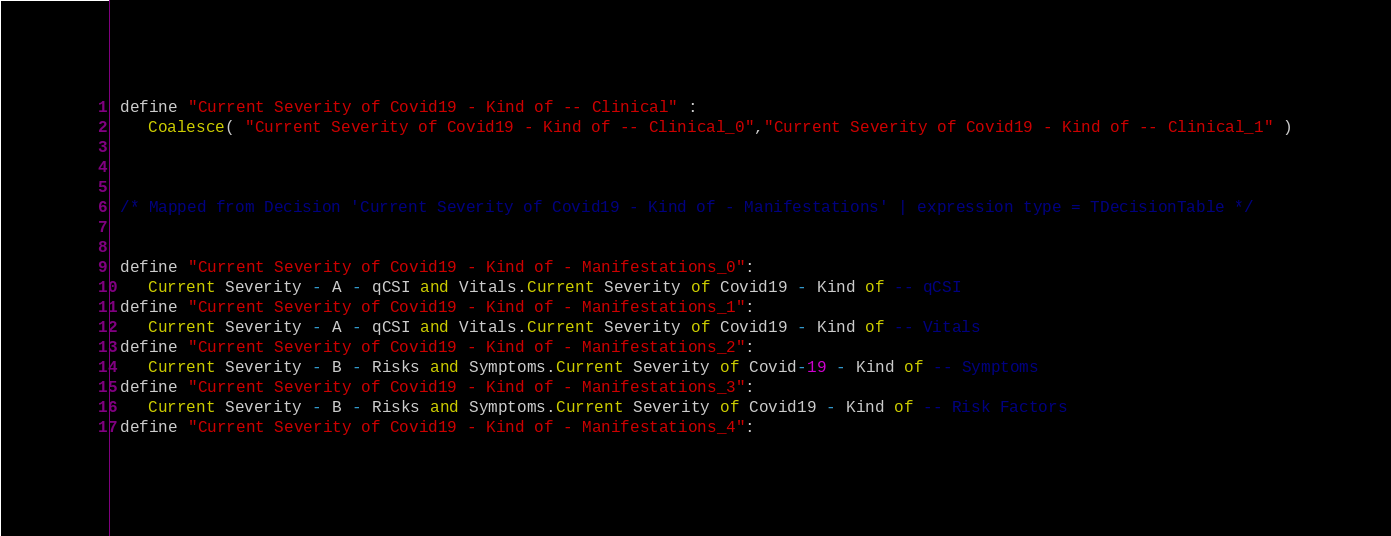<code> <loc_0><loc_0><loc_500><loc_500><_SQL_>
 define "Current Severity of Covid19 - Kind of -- Clinical" :
	Coalesce( "Current Severity of Covid19 - Kind of -- Clinical_0","Current Severity of Covid19 - Kind of -- Clinical_1" )



 /* Mapped from Decision 'Current Severity of Covid19 - Kind of - Manifestations' | expression type = TDecisionTable */ 


 define "Current Severity of Covid19 - Kind of - Manifestations_0": 
	Current Severity - A - qCSI and Vitals.Current Severity of Covid19 - Kind of -- qCSI
 define "Current Severity of Covid19 - Kind of - Manifestations_1": 
	Current Severity - A - qCSI and Vitals.Current Severity of Covid19 - Kind of -- Vitals
 define "Current Severity of Covid19 - Kind of - Manifestations_2": 
	Current Severity - B - Risks and Symptoms.Current Severity of Covid-19 - Kind of -- Symptoms
 define "Current Severity of Covid19 - Kind of - Manifestations_3": 
	Current Severity - B - Risks and Symptoms.Current Severity of Covid19 - Kind of -- Risk Factors
 define "Current Severity of Covid19 - Kind of - Manifestations_4": </code> 